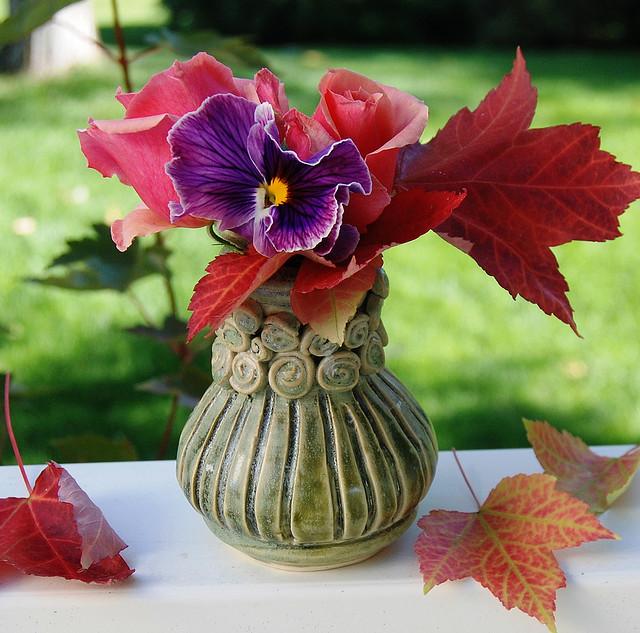How many point are on the front leaf?
Write a very short answer. 3. Are the leaves a summer  color?
Write a very short answer. No. Is it sunny?
Keep it brief. Yes. What color vase is the flower in?
Keep it brief. Green. 